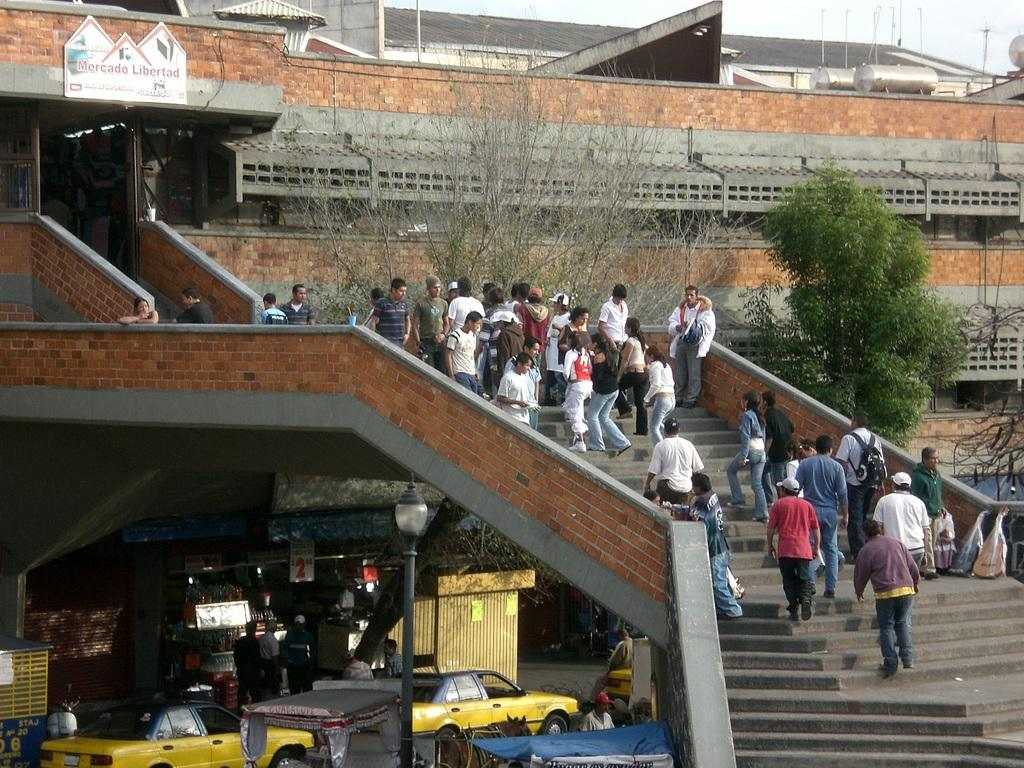What structure is the main subject of the image? There is a bridge in the image. What can be observed about the bridge? The bridge has some states. Where are people located in the image? The people are on a staircase in the image. What else is happening in the image? Vehicles are moving on the road in the image. What type of kettle is being used on the stage in the image? There is no stage or kettle present in the image; it features a bridge, people on a staircase, and vehicles on the road. 